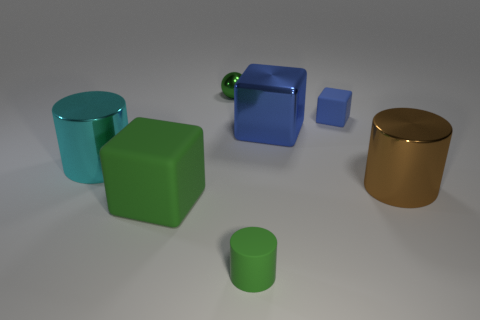How many blue cubes must be subtracted to get 1 blue cubes? 1 Add 1 small cubes. How many objects exist? 8 Subtract all blocks. How many objects are left? 4 Add 4 large blue cubes. How many large blue cubes are left? 5 Add 3 purple metallic spheres. How many purple metallic spheres exist? 3 Subtract 1 green cylinders. How many objects are left? 6 Subtract all large green things. Subtract all cyan things. How many objects are left? 5 